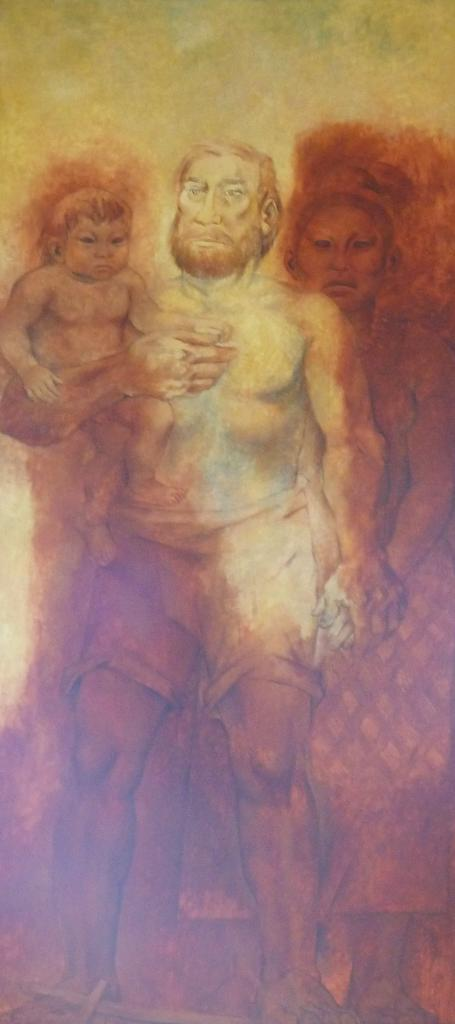What is the main subject of the image? The main subject of the image is depictions of persons. Can you describe the persons in the image? Unfortunately, the provided facts do not give any specific details about the persons in the image. Are there any other elements in the image besides the persons? The given facts do not mention any other elements in the image. How many legs does the toad have in the image? There is no toad present in the image, so it is not possible to determine the number of legs it might have. 